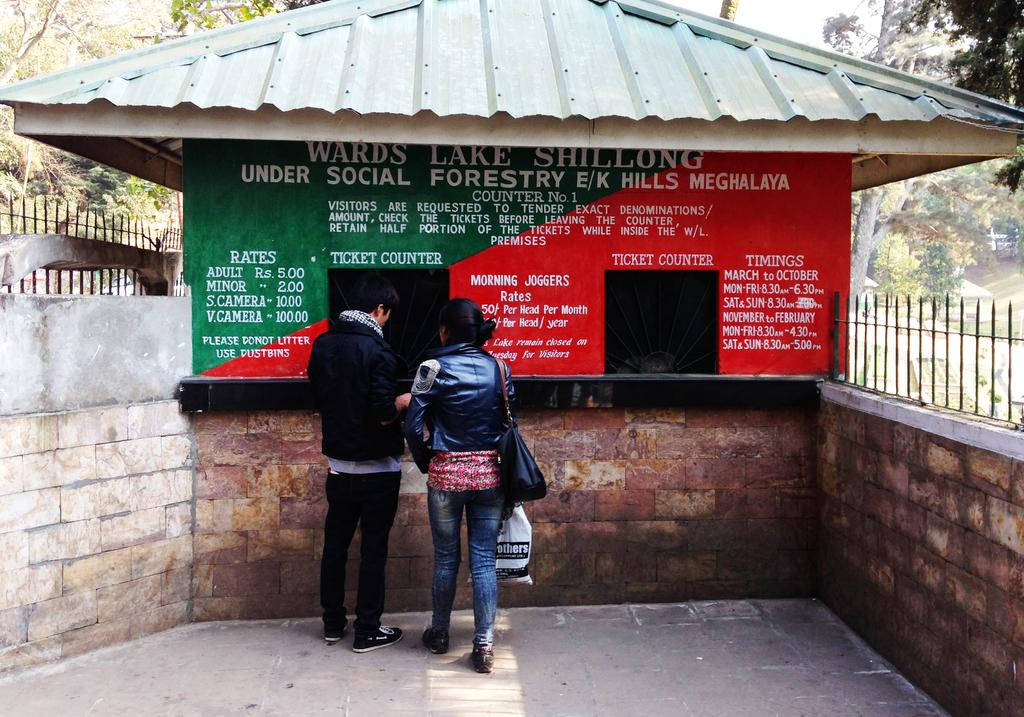How many people are in the image? There are two persons in the image. What are the persons wearing? The persons are wearing black jackets. Where are the persons standing? The persons are standing on the ground. What can be seen in the background of the image? There is a building, two walls, a railing, trees, and the sky visible in the background of the image. What type of sweater is the person wearing in the image? The persons are not wearing sweaters; they are wearing black jackets. Can you tell me how angry the persons look in the image? The provided facts do not mention the emotions or expressions of the persons, so it cannot be determined from the image. 